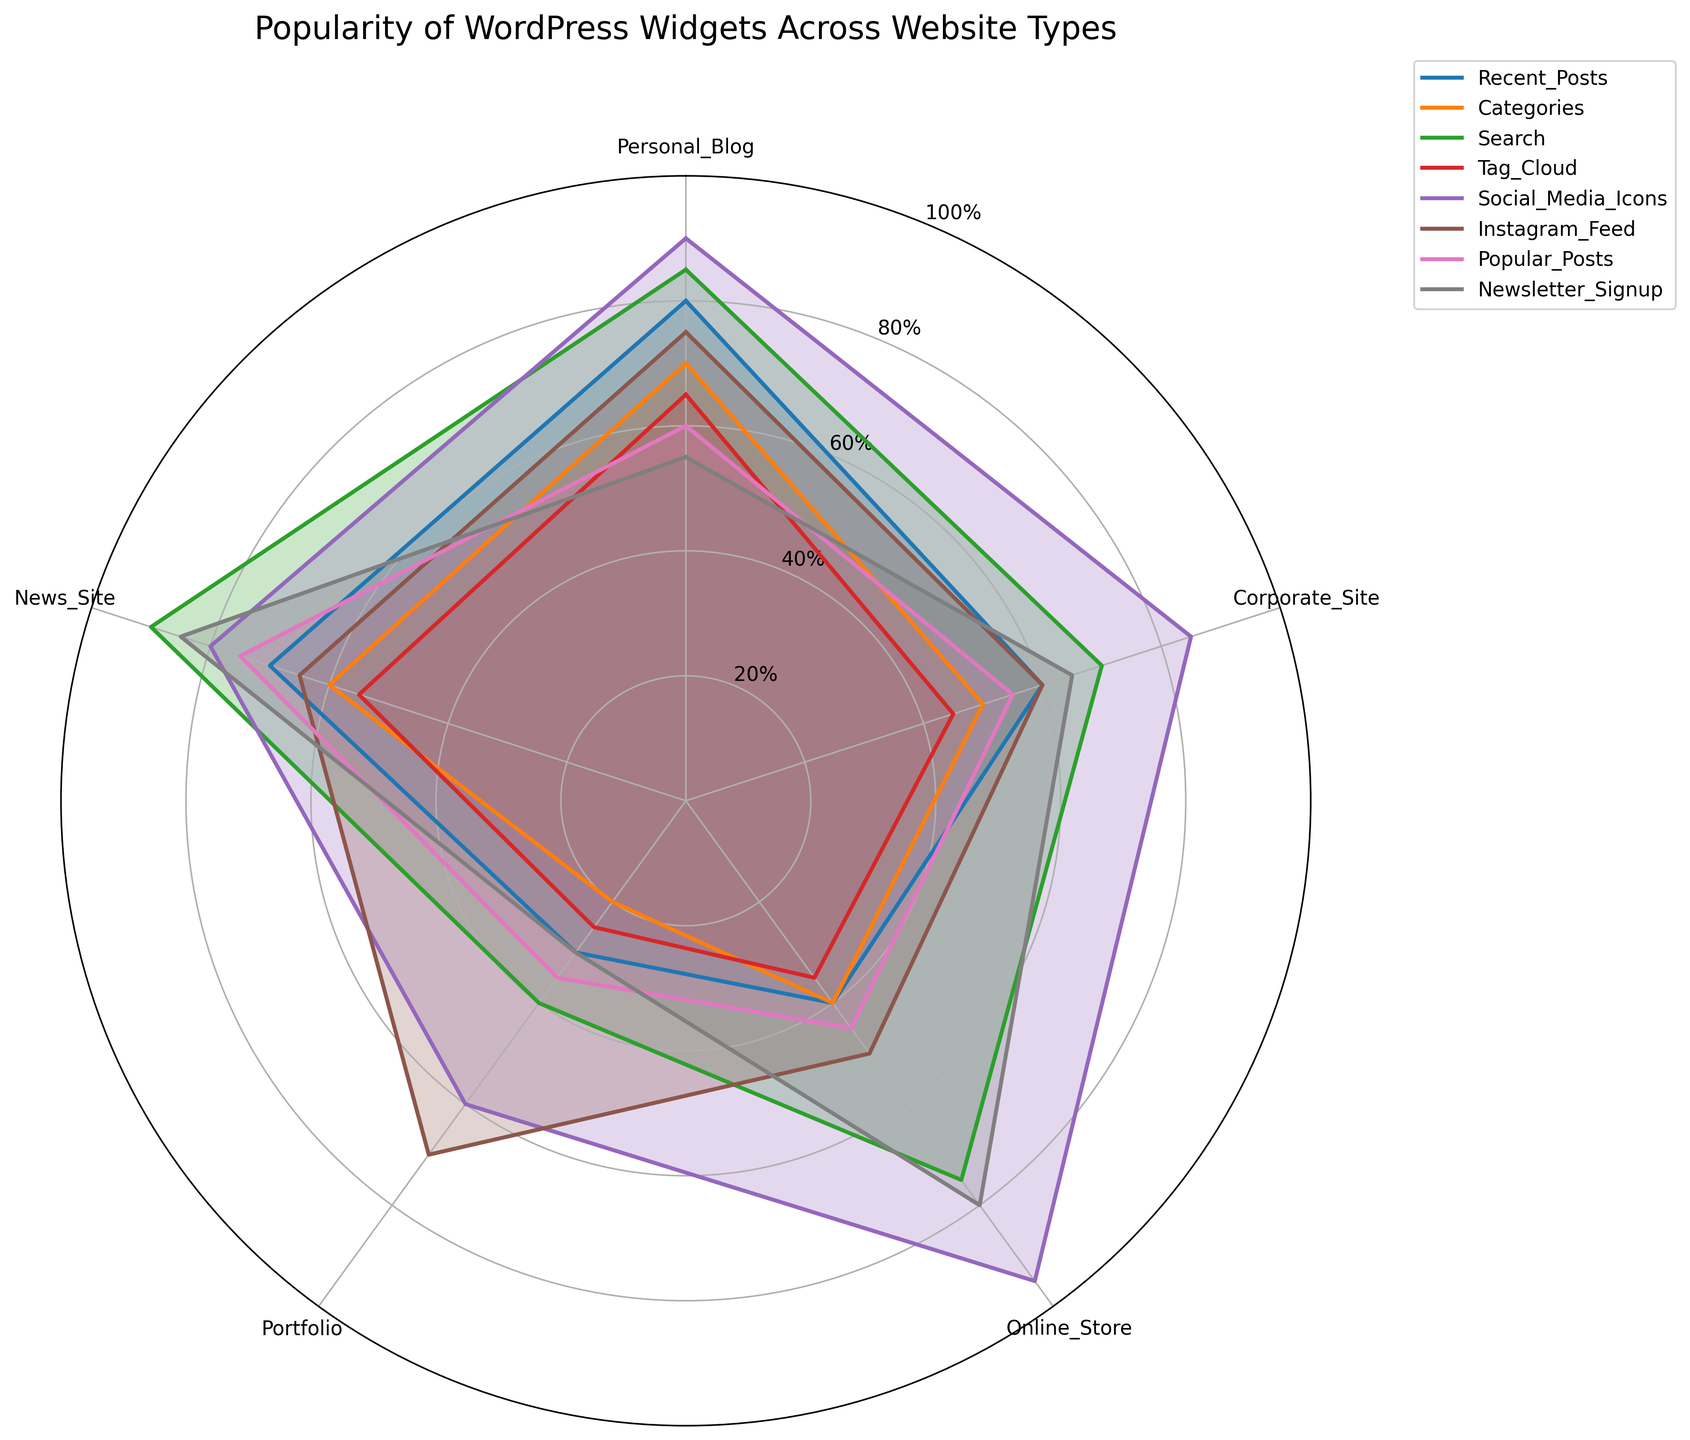What's the title of the figure? The title of the figure is usually located at the top of the chart. For this particular polar area chart, observe the center-top of the figure to find the title.
Answer: Popularity of WordPress Widgets Across Website Types How many types of websites are compared in this polar area chart? To determine the number of website types, count the labels on the outer ring of the polar area chart.
Answer: 5 Which widget is the most popular in Online Stores? Look for the label 'Online Store' and trace the corresponding values for each widget. The widget with the highest value is the most popular.
Answer: Social Media Icons What's the least popular widget in Personal Blogs? Check the section labeled 'Personal Blog' and identify the widget with the smallest radius (value).
Answer: Newsletter Signup Which widget shows the biggest difference in popularity between Personal Blogs and News Sites? Calculate the absolute differences in popularity values of each widget between Personal Blogs and News Sites and find the one with the maximum difference.
Answer: Popular Posts Which widgets have higher popularity in Corporate Sites compared to Portfolios? Compare the values for Corporate Sites and Portfolios for each widget and list the ones where the value for Corporate Sites is greater.
Answer: Recent Posts, Categories, Search, Social Media Icons, Newsletter Signup What is the average popularity value of the 'Search' widget across all website types? Add up the popularity values of the 'Search' widget across all website types and divide by the number of types (5).
Answer: 72 Are there any widgets that have exactly the same popularity value in two different website types? Compare the values for each widget across different website types and see if any are identical.
Answer: None Which widget has the smallest range in popularity across all website types? Calculate the range (difference between the maximum and minimum values) for each widget across all website types and identify the smallest one.
Answer: Popular Posts What trend can be observed about 'Social Media Icons' across different website types? Look at the 'Social Media Icons' values across all website types and describe the general pattern.
Answer: Generally high popularity 